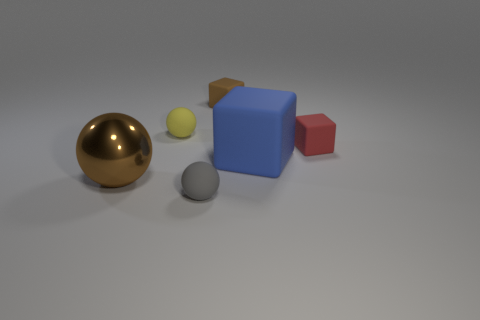Add 2 big cyan matte blocks. How many objects exist? 8 Add 4 tiny yellow spheres. How many tiny yellow spheres are left? 5 Add 1 small yellow balls. How many small yellow balls exist? 2 Subtract 1 red cubes. How many objects are left? 5 Subtract all red rubber objects. Subtract all small brown blocks. How many objects are left? 4 